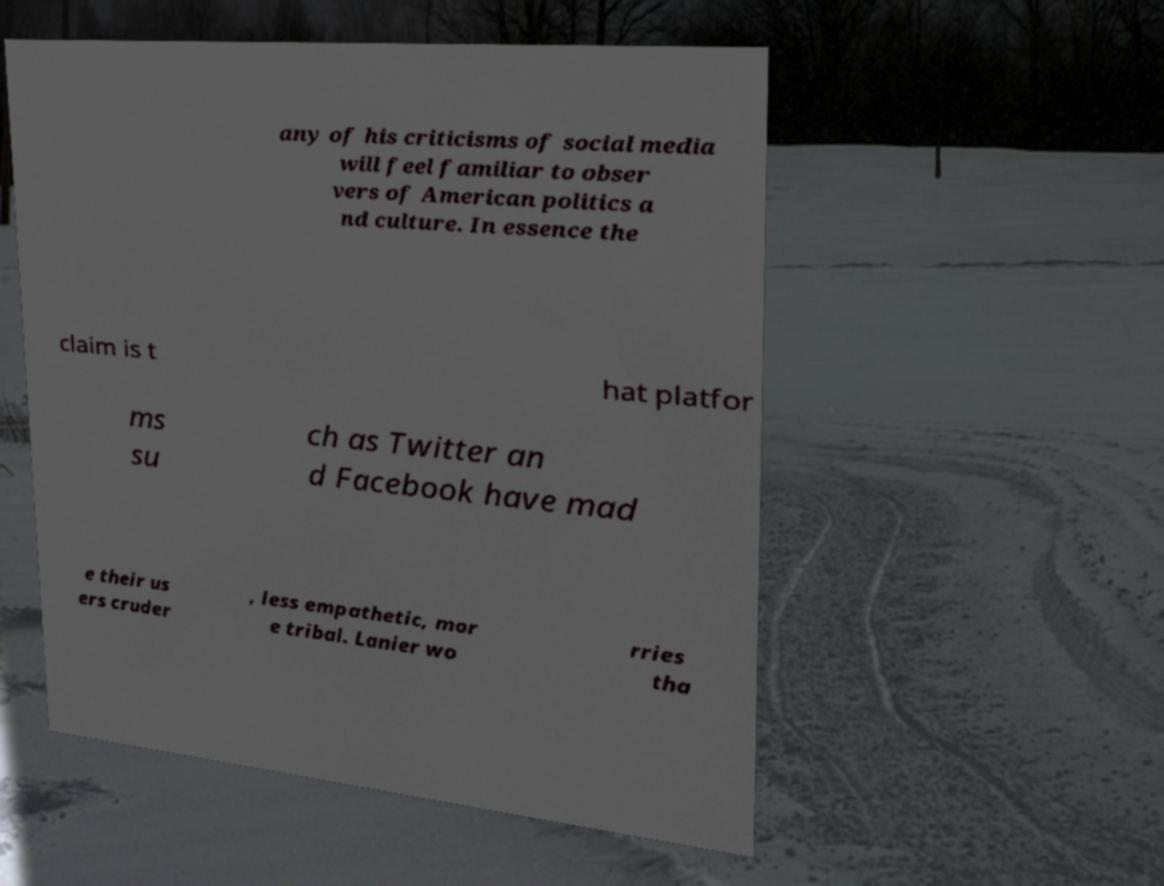Please identify and transcribe the text found in this image. any of his criticisms of social media will feel familiar to obser vers of American politics a nd culture. In essence the claim is t hat platfor ms su ch as Twitter an d Facebook have mad e their us ers cruder , less empathetic, mor e tribal. Lanier wo rries tha 